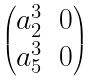Convert formula to latex. <formula><loc_0><loc_0><loc_500><loc_500>\begin{pmatrix} a _ { 2 } ^ { 3 } & 0 \\ a _ { 5 } ^ { 3 } & 0 \end{pmatrix}</formula> 